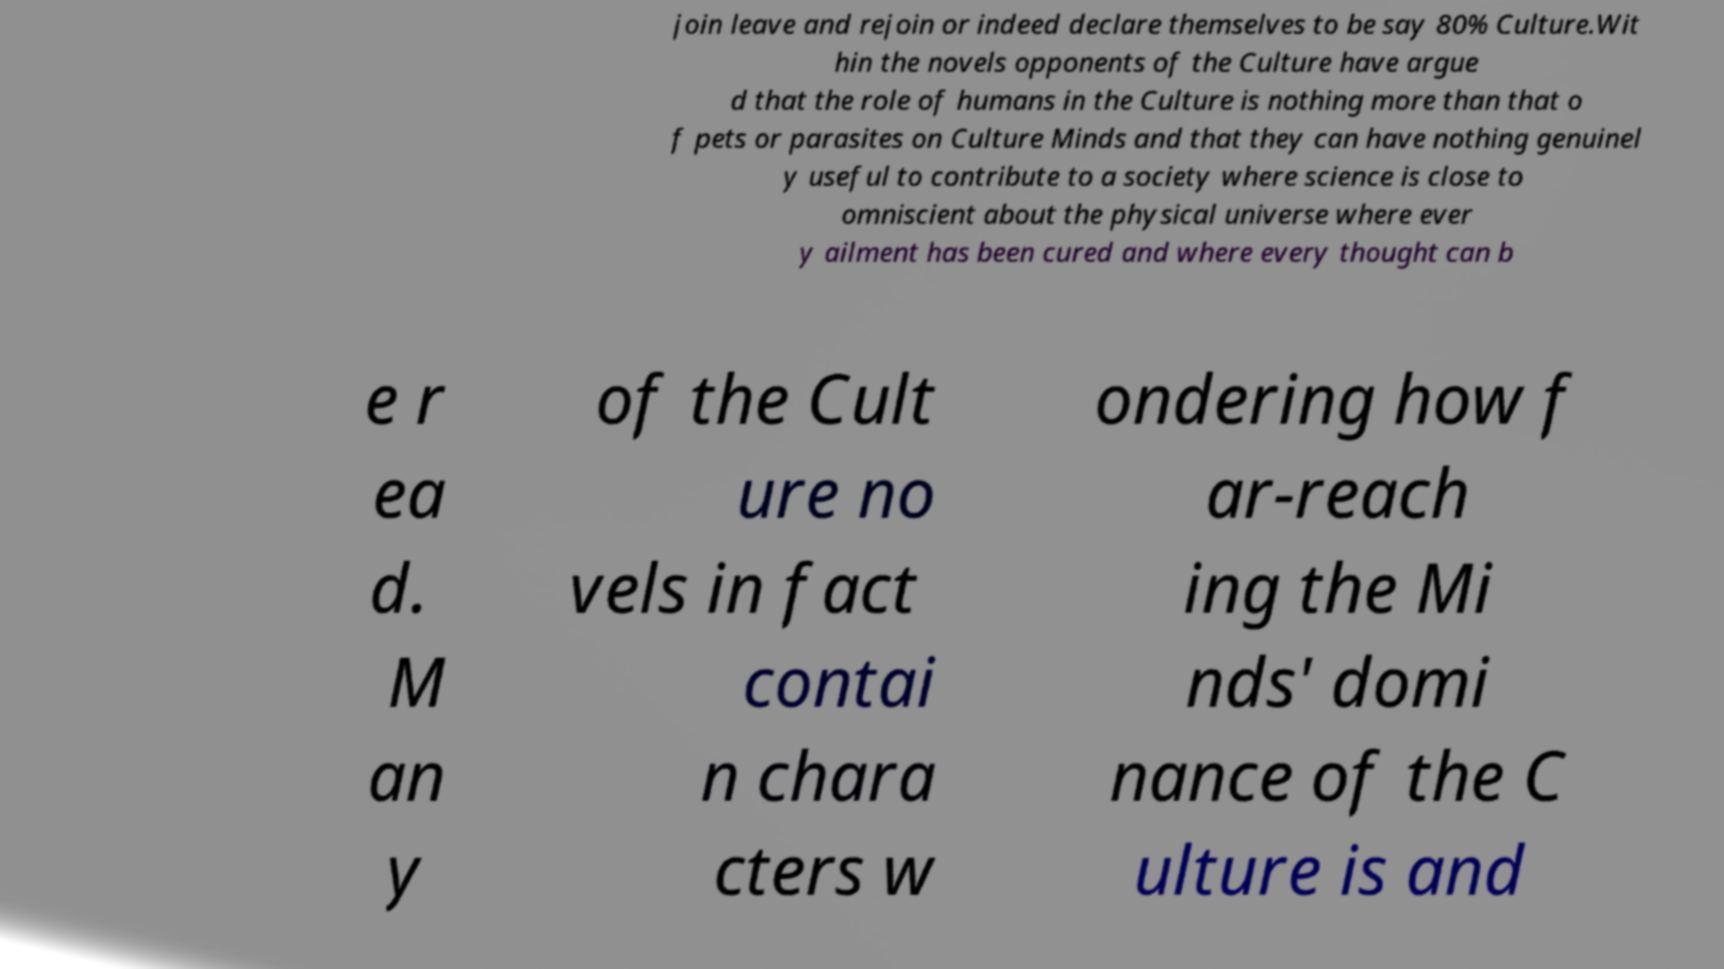Can you read and provide the text displayed in the image?This photo seems to have some interesting text. Can you extract and type it out for me? join leave and rejoin or indeed declare themselves to be say 80% Culture.Wit hin the novels opponents of the Culture have argue d that the role of humans in the Culture is nothing more than that o f pets or parasites on Culture Minds and that they can have nothing genuinel y useful to contribute to a society where science is close to omniscient about the physical universe where ever y ailment has been cured and where every thought can b e r ea d. M an y of the Cult ure no vels in fact contai n chara cters w ondering how f ar-reach ing the Mi nds' domi nance of the C ulture is and 